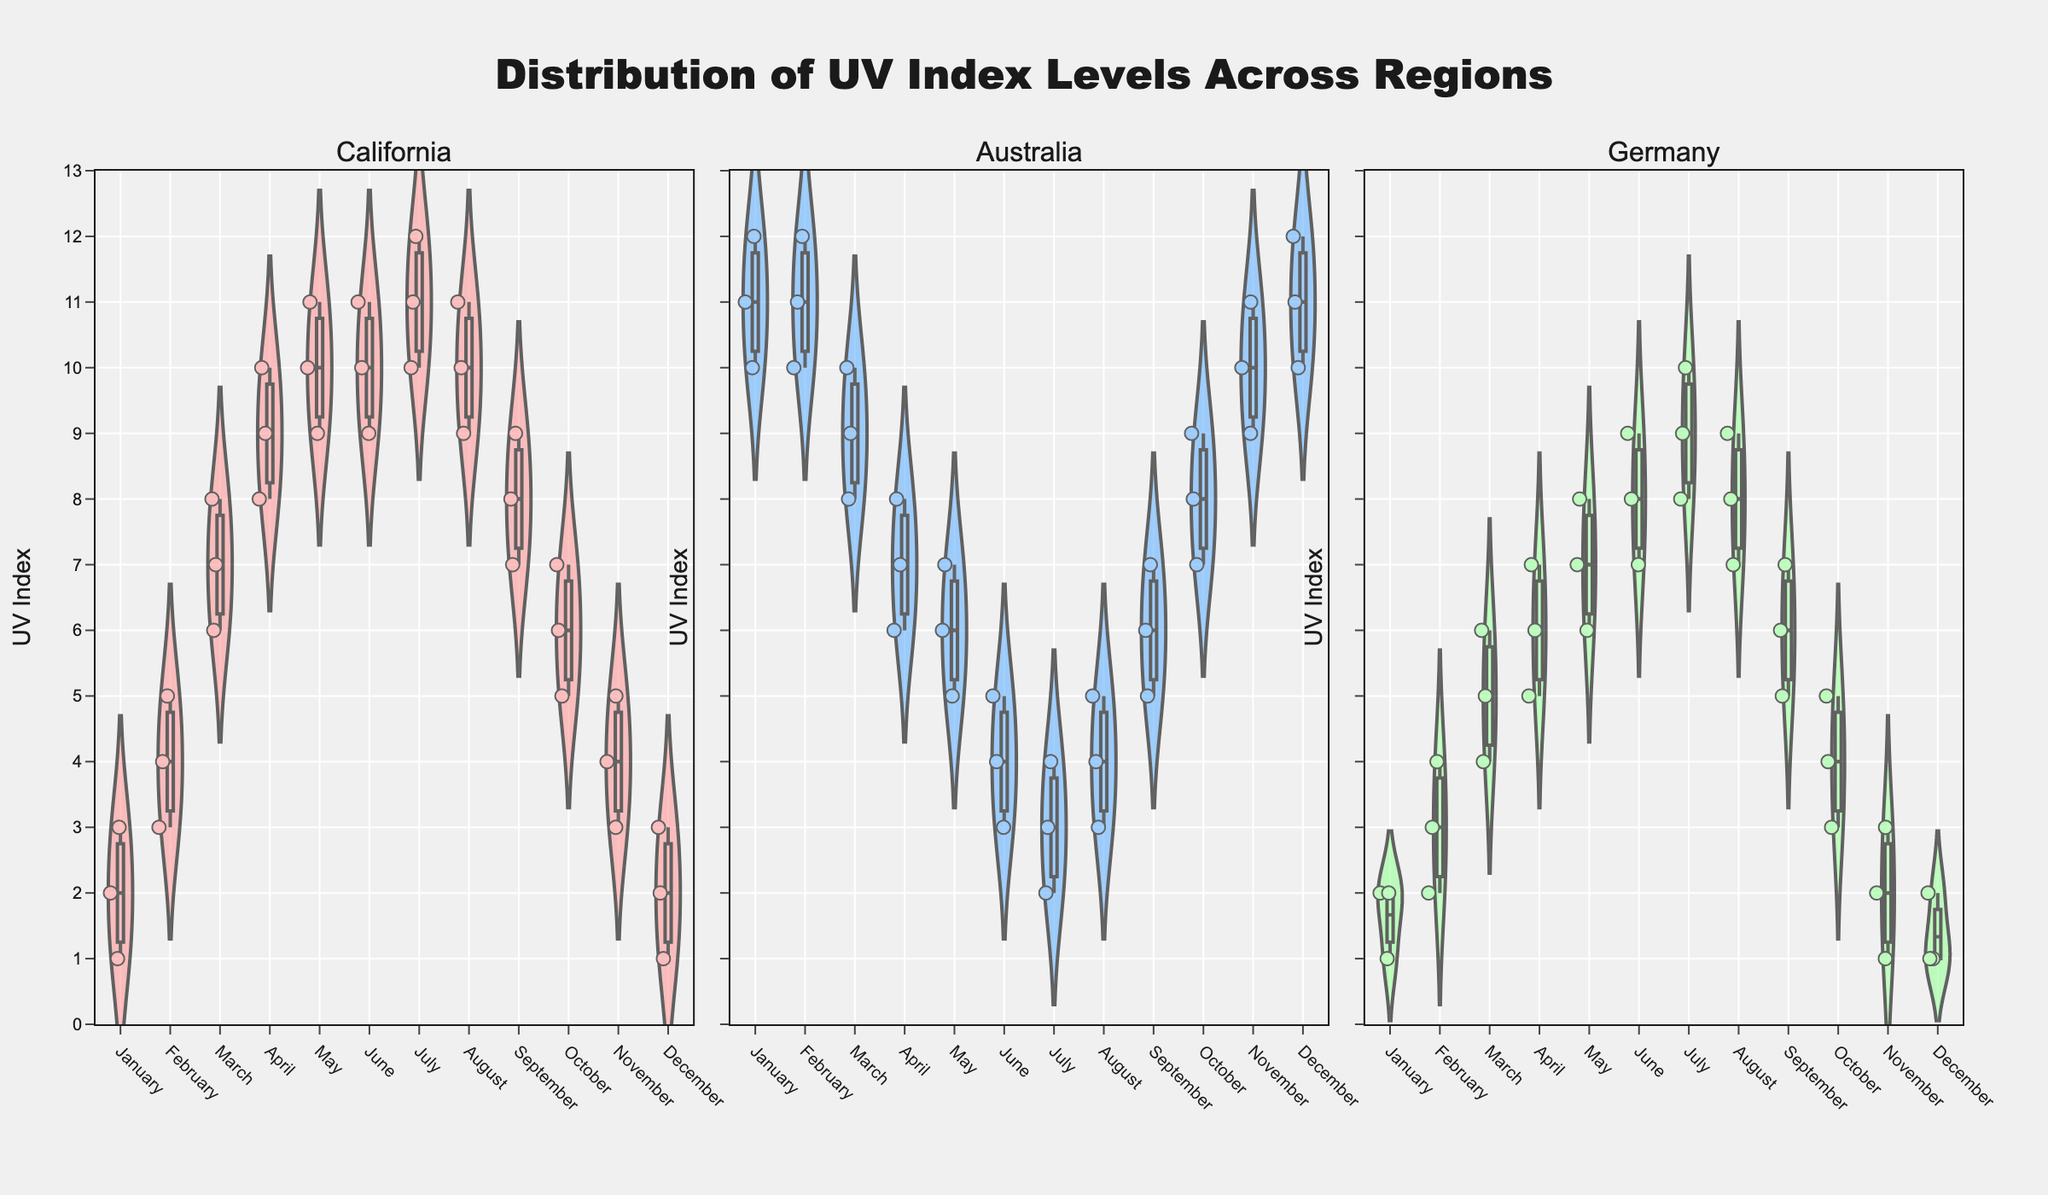What is the UV index range displayed on the y-axis? The y-axis shows the range of UV index levels that are represented in the violin plots. By looking at the y-axis, we see that it ranges from 0 to 13.
Answer: 0 to 13 Which region has the highest UV index levels in January? To find the highest UV index levels in January, we look at the violin plot for January in each region. The plot for Australia in January has UV index levels reaching up to 12.
Answer: Australia Which months in California have the highest median UV index levels? The median in violin plots is shown by the horizontal line within each plot. For California, the highest median UV index levels occur in June, July, and August.
Answer: June, July, and August What is the trend in UV index levels across months for Germany? By analyzing the violin plots for Germany, we observe that the UV index levels increase from January, peaking during June and July, then decrease towards December. This indicates a seasonal variation with higher UV levels in summer.
Answer: Increases from January, peaks in June and July, decreases towards December Comparing the maximum UV index levels in December, which region has the highest value? By examining the violin plots for December, we see that Australia has the highest maximum UV index levels at 12, compared to California and Germany where the maximum is lower.
Answer: Australia Are there any months in Germany with a UV index level of 10 or above? Looking at the violin plots for Germany, the only plots that reach a UV index of 10 are for June and July.
Answer: June and July How does the UV index distribution in July compare between California and Germany? In July, California's UV index levels range from 10 to 12, while Germany's range from 8 to 10. This shows that California has higher UV index levels compared to Germany in July.
Answer: California has higher UV index levels What months in Australia show a decreasing trend in UV index levels? Analyzing the violin plots for Australia, the UV index shows a decreasing trend from January to July.
Answer: January to July Which month has the lowest UV index levels in Germany? The lowest UV index levels in Germany can be observed in December, where the index ranges between 1 and 2.
Answer: December Does California or Germany show a greater variation in UV index levels throughout the year? To assess variation, we need to look at the spread of the violin plots across months. California exhibits a greater year-round variation, ranging from 1 to 12, while Germany ranges from 1 to 10.
Answer: California 